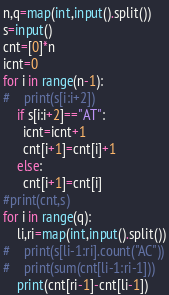Convert code to text. <code><loc_0><loc_0><loc_500><loc_500><_Python_>n,q=map(int,input().split())
s=input()
cnt=[0]*n
icnt=0
for i in range(n-1):
#    print(s[i:i+2])
    if s[i:i+2]=="AT":
      icnt=icnt+1
      cnt[i+1]=cnt[i]+1
    else:
      cnt[i+1]=cnt[i]
#print(cnt,s)
for i in range(q):
    li,ri=map(int,input().split())
#    print(s[li-1:ri].count("AC"))
#    print(sum(cnt[li-1:ri-1]))
    print(cnt[ri-1]-cnt[li-1])</code> 